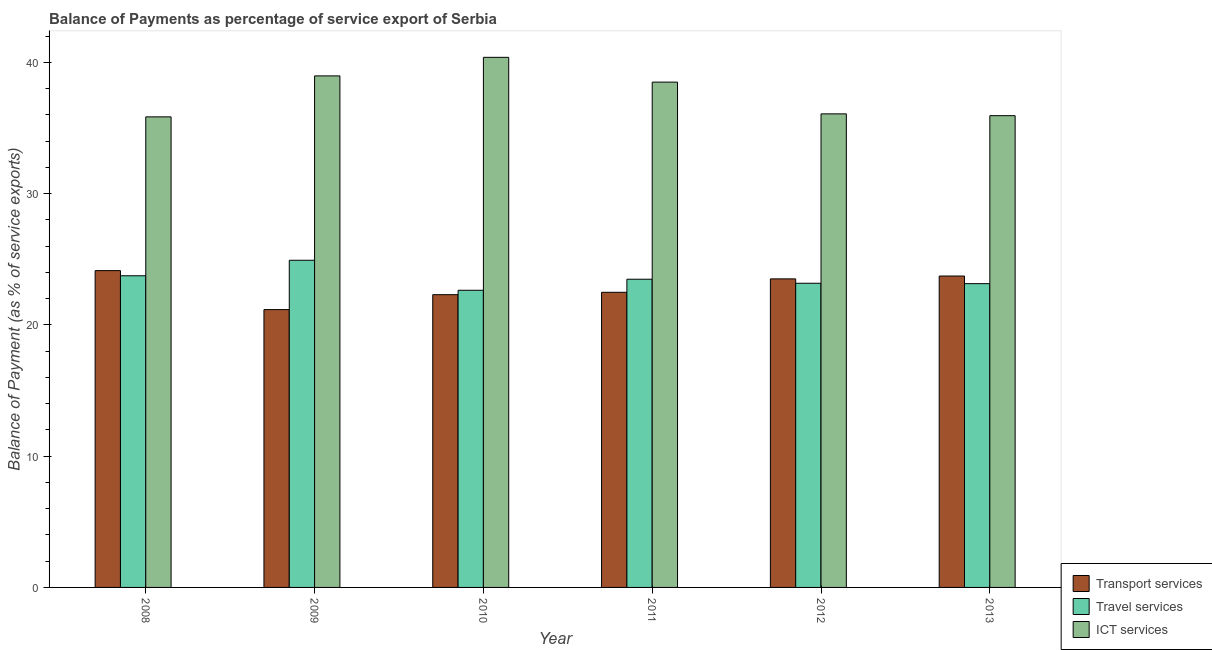How many groups of bars are there?
Give a very brief answer. 6. What is the label of the 3rd group of bars from the left?
Keep it short and to the point. 2010. What is the balance of payment of transport services in 2012?
Provide a succinct answer. 23.51. Across all years, what is the maximum balance of payment of travel services?
Ensure brevity in your answer.  24.93. Across all years, what is the minimum balance of payment of ict services?
Provide a short and direct response. 35.85. In which year was the balance of payment of travel services minimum?
Your answer should be compact. 2010. What is the total balance of payment of transport services in the graph?
Make the answer very short. 137.33. What is the difference between the balance of payment of ict services in 2009 and that in 2010?
Ensure brevity in your answer.  -1.41. What is the difference between the balance of payment of ict services in 2011 and the balance of payment of transport services in 2009?
Keep it short and to the point. -0.47. What is the average balance of payment of transport services per year?
Offer a very short reply. 22.89. In the year 2009, what is the difference between the balance of payment of travel services and balance of payment of ict services?
Make the answer very short. 0. In how many years, is the balance of payment of travel services greater than 4 %?
Provide a short and direct response. 6. What is the ratio of the balance of payment of transport services in 2009 to that in 2013?
Provide a succinct answer. 0.89. Is the difference between the balance of payment of travel services in 2010 and 2012 greater than the difference between the balance of payment of ict services in 2010 and 2012?
Keep it short and to the point. No. What is the difference between the highest and the second highest balance of payment of travel services?
Your answer should be very brief. 1.18. What is the difference between the highest and the lowest balance of payment of transport services?
Make the answer very short. 2.97. What does the 3rd bar from the left in 2013 represents?
Ensure brevity in your answer.  ICT services. What does the 3rd bar from the right in 2010 represents?
Provide a short and direct response. Transport services. How many years are there in the graph?
Ensure brevity in your answer.  6. Are the values on the major ticks of Y-axis written in scientific E-notation?
Your response must be concise. No. Where does the legend appear in the graph?
Ensure brevity in your answer.  Bottom right. How many legend labels are there?
Ensure brevity in your answer.  3. What is the title of the graph?
Provide a short and direct response. Balance of Payments as percentage of service export of Serbia. What is the label or title of the X-axis?
Keep it short and to the point. Year. What is the label or title of the Y-axis?
Your response must be concise. Balance of Payment (as % of service exports). What is the Balance of Payment (as % of service exports) in Transport services in 2008?
Make the answer very short. 24.14. What is the Balance of Payment (as % of service exports) of Travel services in 2008?
Give a very brief answer. 23.74. What is the Balance of Payment (as % of service exports) of ICT services in 2008?
Your response must be concise. 35.85. What is the Balance of Payment (as % of service exports) of Transport services in 2009?
Offer a terse response. 21.17. What is the Balance of Payment (as % of service exports) of Travel services in 2009?
Your response must be concise. 24.93. What is the Balance of Payment (as % of service exports) of ICT services in 2009?
Give a very brief answer. 38.97. What is the Balance of Payment (as % of service exports) in Transport services in 2010?
Keep it short and to the point. 22.3. What is the Balance of Payment (as % of service exports) of Travel services in 2010?
Ensure brevity in your answer.  22.64. What is the Balance of Payment (as % of service exports) of ICT services in 2010?
Provide a succinct answer. 40.39. What is the Balance of Payment (as % of service exports) in Transport services in 2011?
Give a very brief answer. 22.49. What is the Balance of Payment (as % of service exports) of Travel services in 2011?
Ensure brevity in your answer.  23.48. What is the Balance of Payment (as % of service exports) in ICT services in 2011?
Give a very brief answer. 38.5. What is the Balance of Payment (as % of service exports) in Transport services in 2012?
Keep it short and to the point. 23.51. What is the Balance of Payment (as % of service exports) of Travel services in 2012?
Offer a very short reply. 23.17. What is the Balance of Payment (as % of service exports) of ICT services in 2012?
Your answer should be very brief. 36.08. What is the Balance of Payment (as % of service exports) in Transport services in 2013?
Make the answer very short. 23.73. What is the Balance of Payment (as % of service exports) in Travel services in 2013?
Offer a very short reply. 23.15. What is the Balance of Payment (as % of service exports) in ICT services in 2013?
Offer a terse response. 35.94. Across all years, what is the maximum Balance of Payment (as % of service exports) in Transport services?
Offer a terse response. 24.14. Across all years, what is the maximum Balance of Payment (as % of service exports) in Travel services?
Make the answer very short. 24.93. Across all years, what is the maximum Balance of Payment (as % of service exports) of ICT services?
Provide a short and direct response. 40.39. Across all years, what is the minimum Balance of Payment (as % of service exports) of Transport services?
Give a very brief answer. 21.17. Across all years, what is the minimum Balance of Payment (as % of service exports) of Travel services?
Offer a very short reply. 22.64. Across all years, what is the minimum Balance of Payment (as % of service exports) of ICT services?
Your answer should be compact. 35.85. What is the total Balance of Payment (as % of service exports) in Transport services in the graph?
Keep it short and to the point. 137.33. What is the total Balance of Payment (as % of service exports) in Travel services in the graph?
Your answer should be very brief. 141.11. What is the total Balance of Payment (as % of service exports) in ICT services in the graph?
Your answer should be very brief. 225.73. What is the difference between the Balance of Payment (as % of service exports) of Transport services in 2008 and that in 2009?
Give a very brief answer. 2.97. What is the difference between the Balance of Payment (as % of service exports) in Travel services in 2008 and that in 2009?
Your answer should be very brief. -1.18. What is the difference between the Balance of Payment (as % of service exports) of ICT services in 2008 and that in 2009?
Keep it short and to the point. -3.12. What is the difference between the Balance of Payment (as % of service exports) of Transport services in 2008 and that in 2010?
Ensure brevity in your answer.  1.83. What is the difference between the Balance of Payment (as % of service exports) of Travel services in 2008 and that in 2010?
Your response must be concise. 1.1. What is the difference between the Balance of Payment (as % of service exports) in ICT services in 2008 and that in 2010?
Ensure brevity in your answer.  -4.54. What is the difference between the Balance of Payment (as % of service exports) of Transport services in 2008 and that in 2011?
Your answer should be very brief. 1.65. What is the difference between the Balance of Payment (as % of service exports) in Travel services in 2008 and that in 2011?
Your answer should be very brief. 0.26. What is the difference between the Balance of Payment (as % of service exports) in ICT services in 2008 and that in 2011?
Your response must be concise. -2.65. What is the difference between the Balance of Payment (as % of service exports) in Transport services in 2008 and that in 2012?
Offer a terse response. 0.63. What is the difference between the Balance of Payment (as % of service exports) of Travel services in 2008 and that in 2012?
Offer a very short reply. 0.57. What is the difference between the Balance of Payment (as % of service exports) in ICT services in 2008 and that in 2012?
Make the answer very short. -0.23. What is the difference between the Balance of Payment (as % of service exports) in Transport services in 2008 and that in 2013?
Offer a terse response. 0.41. What is the difference between the Balance of Payment (as % of service exports) in Travel services in 2008 and that in 2013?
Your answer should be compact. 0.6. What is the difference between the Balance of Payment (as % of service exports) in ICT services in 2008 and that in 2013?
Provide a short and direct response. -0.09. What is the difference between the Balance of Payment (as % of service exports) of Transport services in 2009 and that in 2010?
Your answer should be compact. -1.14. What is the difference between the Balance of Payment (as % of service exports) of Travel services in 2009 and that in 2010?
Ensure brevity in your answer.  2.29. What is the difference between the Balance of Payment (as % of service exports) of ICT services in 2009 and that in 2010?
Ensure brevity in your answer.  -1.41. What is the difference between the Balance of Payment (as % of service exports) of Transport services in 2009 and that in 2011?
Your answer should be compact. -1.32. What is the difference between the Balance of Payment (as % of service exports) in Travel services in 2009 and that in 2011?
Give a very brief answer. 1.45. What is the difference between the Balance of Payment (as % of service exports) of ICT services in 2009 and that in 2011?
Ensure brevity in your answer.  0.47. What is the difference between the Balance of Payment (as % of service exports) in Transport services in 2009 and that in 2012?
Provide a short and direct response. -2.34. What is the difference between the Balance of Payment (as % of service exports) in Travel services in 2009 and that in 2012?
Ensure brevity in your answer.  1.75. What is the difference between the Balance of Payment (as % of service exports) in ICT services in 2009 and that in 2012?
Your response must be concise. 2.89. What is the difference between the Balance of Payment (as % of service exports) in Transport services in 2009 and that in 2013?
Keep it short and to the point. -2.56. What is the difference between the Balance of Payment (as % of service exports) in Travel services in 2009 and that in 2013?
Provide a short and direct response. 1.78. What is the difference between the Balance of Payment (as % of service exports) in ICT services in 2009 and that in 2013?
Make the answer very short. 3.03. What is the difference between the Balance of Payment (as % of service exports) of Transport services in 2010 and that in 2011?
Offer a very short reply. -0.18. What is the difference between the Balance of Payment (as % of service exports) in Travel services in 2010 and that in 2011?
Your response must be concise. -0.84. What is the difference between the Balance of Payment (as % of service exports) in ICT services in 2010 and that in 2011?
Your answer should be very brief. 1.89. What is the difference between the Balance of Payment (as % of service exports) of Transport services in 2010 and that in 2012?
Keep it short and to the point. -1.2. What is the difference between the Balance of Payment (as % of service exports) of Travel services in 2010 and that in 2012?
Provide a succinct answer. -0.53. What is the difference between the Balance of Payment (as % of service exports) of ICT services in 2010 and that in 2012?
Your answer should be compact. 4.31. What is the difference between the Balance of Payment (as % of service exports) in Transport services in 2010 and that in 2013?
Your answer should be compact. -1.42. What is the difference between the Balance of Payment (as % of service exports) in Travel services in 2010 and that in 2013?
Provide a succinct answer. -0.51. What is the difference between the Balance of Payment (as % of service exports) of ICT services in 2010 and that in 2013?
Give a very brief answer. 4.45. What is the difference between the Balance of Payment (as % of service exports) of Transport services in 2011 and that in 2012?
Offer a terse response. -1.02. What is the difference between the Balance of Payment (as % of service exports) of Travel services in 2011 and that in 2012?
Provide a succinct answer. 0.31. What is the difference between the Balance of Payment (as % of service exports) of ICT services in 2011 and that in 2012?
Your answer should be compact. 2.42. What is the difference between the Balance of Payment (as % of service exports) of Transport services in 2011 and that in 2013?
Give a very brief answer. -1.24. What is the difference between the Balance of Payment (as % of service exports) of Travel services in 2011 and that in 2013?
Give a very brief answer. 0.34. What is the difference between the Balance of Payment (as % of service exports) in ICT services in 2011 and that in 2013?
Your answer should be very brief. 2.56. What is the difference between the Balance of Payment (as % of service exports) in Transport services in 2012 and that in 2013?
Your answer should be compact. -0.22. What is the difference between the Balance of Payment (as % of service exports) of Travel services in 2012 and that in 2013?
Give a very brief answer. 0.03. What is the difference between the Balance of Payment (as % of service exports) in ICT services in 2012 and that in 2013?
Provide a short and direct response. 0.14. What is the difference between the Balance of Payment (as % of service exports) of Transport services in 2008 and the Balance of Payment (as % of service exports) of Travel services in 2009?
Give a very brief answer. -0.79. What is the difference between the Balance of Payment (as % of service exports) of Transport services in 2008 and the Balance of Payment (as % of service exports) of ICT services in 2009?
Offer a terse response. -14.84. What is the difference between the Balance of Payment (as % of service exports) of Travel services in 2008 and the Balance of Payment (as % of service exports) of ICT services in 2009?
Offer a very short reply. -15.23. What is the difference between the Balance of Payment (as % of service exports) in Transport services in 2008 and the Balance of Payment (as % of service exports) in Travel services in 2010?
Provide a short and direct response. 1.5. What is the difference between the Balance of Payment (as % of service exports) of Transport services in 2008 and the Balance of Payment (as % of service exports) of ICT services in 2010?
Make the answer very short. -16.25. What is the difference between the Balance of Payment (as % of service exports) of Travel services in 2008 and the Balance of Payment (as % of service exports) of ICT services in 2010?
Your response must be concise. -16.64. What is the difference between the Balance of Payment (as % of service exports) of Transport services in 2008 and the Balance of Payment (as % of service exports) of Travel services in 2011?
Offer a very short reply. 0.66. What is the difference between the Balance of Payment (as % of service exports) of Transport services in 2008 and the Balance of Payment (as % of service exports) of ICT services in 2011?
Your answer should be compact. -14.36. What is the difference between the Balance of Payment (as % of service exports) in Travel services in 2008 and the Balance of Payment (as % of service exports) in ICT services in 2011?
Give a very brief answer. -14.75. What is the difference between the Balance of Payment (as % of service exports) in Transport services in 2008 and the Balance of Payment (as % of service exports) in ICT services in 2012?
Keep it short and to the point. -11.94. What is the difference between the Balance of Payment (as % of service exports) of Travel services in 2008 and the Balance of Payment (as % of service exports) of ICT services in 2012?
Provide a short and direct response. -12.34. What is the difference between the Balance of Payment (as % of service exports) in Transport services in 2008 and the Balance of Payment (as % of service exports) in ICT services in 2013?
Provide a succinct answer. -11.8. What is the difference between the Balance of Payment (as % of service exports) of Travel services in 2008 and the Balance of Payment (as % of service exports) of ICT services in 2013?
Offer a terse response. -12.2. What is the difference between the Balance of Payment (as % of service exports) in Transport services in 2009 and the Balance of Payment (as % of service exports) in Travel services in 2010?
Provide a succinct answer. -1.47. What is the difference between the Balance of Payment (as % of service exports) of Transport services in 2009 and the Balance of Payment (as % of service exports) of ICT services in 2010?
Your response must be concise. -19.22. What is the difference between the Balance of Payment (as % of service exports) of Travel services in 2009 and the Balance of Payment (as % of service exports) of ICT services in 2010?
Your response must be concise. -15.46. What is the difference between the Balance of Payment (as % of service exports) of Transport services in 2009 and the Balance of Payment (as % of service exports) of Travel services in 2011?
Provide a succinct answer. -2.31. What is the difference between the Balance of Payment (as % of service exports) in Transport services in 2009 and the Balance of Payment (as % of service exports) in ICT services in 2011?
Provide a succinct answer. -17.33. What is the difference between the Balance of Payment (as % of service exports) in Travel services in 2009 and the Balance of Payment (as % of service exports) in ICT services in 2011?
Give a very brief answer. -13.57. What is the difference between the Balance of Payment (as % of service exports) in Transport services in 2009 and the Balance of Payment (as % of service exports) in Travel services in 2012?
Keep it short and to the point. -2.01. What is the difference between the Balance of Payment (as % of service exports) in Transport services in 2009 and the Balance of Payment (as % of service exports) in ICT services in 2012?
Make the answer very short. -14.91. What is the difference between the Balance of Payment (as % of service exports) in Travel services in 2009 and the Balance of Payment (as % of service exports) in ICT services in 2012?
Your answer should be very brief. -11.15. What is the difference between the Balance of Payment (as % of service exports) of Transport services in 2009 and the Balance of Payment (as % of service exports) of Travel services in 2013?
Provide a short and direct response. -1.98. What is the difference between the Balance of Payment (as % of service exports) in Transport services in 2009 and the Balance of Payment (as % of service exports) in ICT services in 2013?
Give a very brief answer. -14.78. What is the difference between the Balance of Payment (as % of service exports) in Travel services in 2009 and the Balance of Payment (as % of service exports) in ICT services in 2013?
Your answer should be very brief. -11.01. What is the difference between the Balance of Payment (as % of service exports) in Transport services in 2010 and the Balance of Payment (as % of service exports) in Travel services in 2011?
Your response must be concise. -1.18. What is the difference between the Balance of Payment (as % of service exports) of Transport services in 2010 and the Balance of Payment (as % of service exports) of ICT services in 2011?
Your answer should be very brief. -16.2. What is the difference between the Balance of Payment (as % of service exports) in Travel services in 2010 and the Balance of Payment (as % of service exports) in ICT services in 2011?
Make the answer very short. -15.86. What is the difference between the Balance of Payment (as % of service exports) of Transport services in 2010 and the Balance of Payment (as % of service exports) of Travel services in 2012?
Your answer should be compact. -0.87. What is the difference between the Balance of Payment (as % of service exports) in Transport services in 2010 and the Balance of Payment (as % of service exports) in ICT services in 2012?
Your response must be concise. -13.78. What is the difference between the Balance of Payment (as % of service exports) of Travel services in 2010 and the Balance of Payment (as % of service exports) of ICT services in 2012?
Offer a very short reply. -13.44. What is the difference between the Balance of Payment (as % of service exports) of Transport services in 2010 and the Balance of Payment (as % of service exports) of Travel services in 2013?
Offer a terse response. -0.84. What is the difference between the Balance of Payment (as % of service exports) in Transport services in 2010 and the Balance of Payment (as % of service exports) in ICT services in 2013?
Offer a very short reply. -13.64. What is the difference between the Balance of Payment (as % of service exports) of Travel services in 2010 and the Balance of Payment (as % of service exports) of ICT services in 2013?
Provide a short and direct response. -13.3. What is the difference between the Balance of Payment (as % of service exports) in Transport services in 2011 and the Balance of Payment (as % of service exports) in Travel services in 2012?
Your response must be concise. -0.69. What is the difference between the Balance of Payment (as % of service exports) of Transport services in 2011 and the Balance of Payment (as % of service exports) of ICT services in 2012?
Ensure brevity in your answer.  -13.59. What is the difference between the Balance of Payment (as % of service exports) in Travel services in 2011 and the Balance of Payment (as % of service exports) in ICT services in 2012?
Make the answer very short. -12.6. What is the difference between the Balance of Payment (as % of service exports) in Transport services in 2011 and the Balance of Payment (as % of service exports) in Travel services in 2013?
Offer a very short reply. -0.66. What is the difference between the Balance of Payment (as % of service exports) of Transport services in 2011 and the Balance of Payment (as % of service exports) of ICT services in 2013?
Your answer should be very brief. -13.46. What is the difference between the Balance of Payment (as % of service exports) in Travel services in 2011 and the Balance of Payment (as % of service exports) in ICT services in 2013?
Your response must be concise. -12.46. What is the difference between the Balance of Payment (as % of service exports) in Transport services in 2012 and the Balance of Payment (as % of service exports) in Travel services in 2013?
Give a very brief answer. 0.36. What is the difference between the Balance of Payment (as % of service exports) in Transport services in 2012 and the Balance of Payment (as % of service exports) in ICT services in 2013?
Offer a very short reply. -12.44. What is the difference between the Balance of Payment (as % of service exports) of Travel services in 2012 and the Balance of Payment (as % of service exports) of ICT services in 2013?
Offer a very short reply. -12.77. What is the average Balance of Payment (as % of service exports) in Transport services per year?
Offer a very short reply. 22.89. What is the average Balance of Payment (as % of service exports) in Travel services per year?
Provide a succinct answer. 23.52. What is the average Balance of Payment (as % of service exports) in ICT services per year?
Provide a short and direct response. 37.62. In the year 2008, what is the difference between the Balance of Payment (as % of service exports) in Transport services and Balance of Payment (as % of service exports) in Travel services?
Provide a short and direct response. 0.39. In the year 2008, what is the difference between the Balance of Payment (as % of service exports) of Transport services and Balance of Payment (as % of service exports) of ICT services?
Give a very brief answer. -11.71. In the year 2008, what is the difference between the Balance of Payment (as % of service exports) in Travel services and Balance of Payment (as % of service exports) in ICT services?
Provide a short and direct response. -12.11. In the year 2009, what is the difference between the Balance of Payment (as % of service exports) in Transport services and Balance of Payment (as % of service exports) in Travel services?
Ensure brevity in your answer.  -3.76. In the year 2009, what is the difference between the Balance of Payment (as % of service exports) of Transport services and Balance of Payment (as % of service exports) of ICT services?
Your response must be concise. -17.81. In the year 2009, what is the difference between the Balance of Payment (as % of service exports) in Travel services and Balance of Payment (as % of service exports) in ICT services?
Your answer should be compact. -14.05. In the year 2010, what is the difference between the Balance of Payment (as % of service exports) of Transport services and Balance of Payment (as % of service exports) of Travel services?
Your answer should be compact. -0.34. In the year 2010, what is the difference between the Balance of Payment (as % of service exports) of Transport services and Balance of Payment (as % of service exports) of ICT services?
Keep it short and to the point. -18.08. In the year 2010, what is the difference between the Balance of Payment (as % of service exports) in Travel services and Balance of Payment (as % of service exports) in ICT services?
Make the answer very short. -17.75. In the year 2011, what is the difference between the Balance of Payment (as % of service exports) in Transport services and Balance of Payment (as % of service exports) in Travel services?
Provide a succinct answer. -0.99. In the year 2011, what is the difference between the Balance of Payment (as % of service exports) in Transport services and Balance of Payment (as % of service exports) in ICT services?
Give a very brief answer. -16.01. In the year 2011, what is the difference between the Balance of Payment (as % of service exports) of Travel services and Balance of Payment (as % of service exports) of ICT services?
Make the answer very short. -15.02. In the year 2012, what is the difference between the Balance of Payment (as % of service exports) in Transport services and Balance of Payment (as % of service exports) in Travel services?
Your response must be concise. 0.33. In the year 2012, what is the difference between the Balance of Payment (as % of service exports) of Transport services and Balance of Payment (as % of service exports) of ICT services?
Your response must be concise. -12.57. In the year 2012, what is the difference between the Balance of Payment (as % of service exports) of Travel services and Balance of Payment (as % of service exports) of ICT services?
Offer a terse response. -12.91. In the year 2013, what is the difference between the Balance of Payment (as % of service exports) in Transport services and Balance of Payment (as % of service exports) in Travel services?
Ensure brevity in your answer.  0.58. In the year 2013, what is the difference between the Balance of Payment (as % of service exports) in Transport services and Balance of Payment (as % of service exports) in ICT services?
Your response must be concise. -12.22. In the year 2013, what is the difference between the Balance of Payment (as % of service exports) of Travel services and Balance of Payment (as % of service exports) of ICT services?
Your response must be concise. -12.8. What is the ratio of the Balance of Payment (as % of service exports) of Transport services in 2008 to that in 2009?
Ensure brevity in your answer.  1.14. What is the ratio of the Balance of Payment (as % of service exports) of Travel services in 2008 to that in 2009?
Your response must be concise. 0.95. What is the ratio of the Balance of Payment (as % of service exports) of ICT services in 2008 to that in 2009?
Your response must be concise. 0.92. What is the ratio of the Balance of Payment (as % of service exports) of Transport services in 2008 to that in 2010?
Keep it short and to the point. 1.08. What is the ratio of the Balance of Payment (as % of service exports) in Travel services in 2008 to that in 2010?
Make the answer very short. 1.05. What is the ratio of the Balance of Payment (as % of service exports) of ICT services in 2008 to that in 2010?
Your response must be concise. 0.89. What is the ratio of the Balance of Payment (as % of service exports) in Transport services in 2008 to that in 2011?
Make the answer very short. 1.07. What is the ratio of the Balance of Payment (as % of service exports) in Travel services in 2008 to that in 2011?
Offer a very short reply. 1.01. What is the ratio of the Balance of Payment (as % of service exports) in ICT services in 2008 to that in 2011?
Ensure brevity in your answer.  0.93. What is the ratio of the Balance of Payment (as % of service exports) in Transport services in 2008 to that in 2012?
Ensure brevity in your answer.  1.03. What is the ratio of the Balance of Payment (as % of service exports) of Travel services in 2008 to that in 2012?
Give a very brief answer. 1.02. What is the ratio of the Balance of Payment (as % of service exports) in Transport services in 2008 to that in 2013?
Your answer should be very brief. 1.02. What is the ratio of the Balance of Payment (as % of service exports) in Travel services in 2008 to that in 2013?
Your answer should be very brief. 1.03. What is the ratio of the Balance of Payment (as % of service exports) of Transport services in 2009 to that in 2010?
Provide a short and direct response. 0.95. What is the ratio of the Balance of Payment (as % of service exports) of Travel services in 2009 to that in 2010?
Your answer should be very brief. 1.1. What is the ratio of the Balance of Payment (as % of service exports) in Transport services in 2009 to that in 2011?
Your response must be concise. 0.94. What is the ratio of the Balance of Payment (as % of service exports) in Travel services in 2009 to that in 2011?
Make the answer very short. 1.06. What is the ratio of the Balance of Payment (as % of service exports) in ICT services in 2009 to that in 2011?
Your response must be concise. 1.01. What is the ratio of the Balance of Payment (as % of service exports) of Transport services in 2009 to that in 2012?
Offer a very short reply. 0.9. What is the ratio of the Balance of Payment (as % of service exports) in Travel services in 2009 to that in 2012?
Offer a terse response. 1.08. What is the ratio of the Balance of Payment (as % of service exports) in ICT services in 2009 to that in 2012?
Keep it short and to the point. 1.08. What is the ratio of the Balance of Payment (as % of service exports) in Transport services in 2009 to that in 2013?
Provide a succinct answer. 0.89. What is the ratio of the Balance of Payment (as % of service exports) of Travel services in 2009 to that in 2013?
Your response must be concise. 1.08. What is the ratio of the Balance of Payment (as % of service exports) in ICT services in 2009 to that in 2013?
Give a very brief answer. 1.08. What is the ratio of the Balance of Payment (as % of service exports) of Travel services in 2010 to that in 2011?
Your answer should be compact. 0.96. What is the ratio of the Balance of Payment (as % of service exports) of ICT services in 2010 to that in 2011?
Ensure brevity in your answer.  1.05. What is the ratio of the Balance of Payment (as % of service exports) of Transport services in 2010 to that in 2012?
Give a very brief answer. 0.95. What is the ratio of the Balance of Payment (as % of service exports) of Travel services in 2010 to that in 2012?
Give a very brief answer. 0.98. What is the ratio of the Balance of Payment (as % of service exports) of ICT services in 2010 to that in 2012?
Provide a short and direct response. 1.12. What is the ratio of the Balance of Payment (as % of service exports) of Transport services in 2010 to that in 2013?
Offer a terse response. 0.94. What is the ratio of the Balance of Payment (as % of service exports) of Travel services in 2010 to that in 2013?
Ensure brevity in your answer.  0.98. What is the ratio of the Balance of Payment (as % of service exports) in ICT services in 2010 to that in 2013?
Your response must be concise. 1.12. What is the ratio of the Balance of Payment (as % of service exports) of Transport services in 2011 to that in 2012?
Offer a very short reply. 0.96. What is the ratio of the Balance of Payment (as % of service exports) in Travel services in 2011 to that in 2012?
Provide a succinct answer. 1.01. What is the ratio of the Balance of Payment (as % of service exports) in ICT services in 2011 to that in 2012?
Your answer should be compact. 1.07. What is the ratio of the Balance of Payment (as % of service exports) of Transport services in 2011 to that in 2013?
Your response must be concise. 0.95. What is the ratio of the Balance of Payment (as % of service exports) of Travel services in 2011 to that in 2013?
Your response must be concise. 1.01. What is the ratio of the Balance of Payment (as % of service exports) of ICT services in 2011 to that in 2013?
Offer a very short reply. 1.07. What is the ratio of the Balance of Payment (as % of service exports) of Transport services in 2012 to that in 2013?
Provide a short and direct response. 0.99. What is the difference between the highest and the second highest Balance of Payment (as % of service exports) in Transport services?
Your answer should be compact. 0.41. What is the difference between the highest and the second highest Balance of Payment (as % of service exports) in Travel services?
Offer a very short reply. 1.18. What is the difference between the highest and the second highest Balance of Payment (as % of service exports) in ICT services?
Ensure brevity in your answer.  1.41. What is the difference between the highest and the lowest Balance of Payment (as % of service exports) of Transport services?
Your answer should be very brief. 2.97. What is the difference between the highest and the lowest Balance of Payment (as % of service exports) in Travel services?
Give a very brief answer. 2.29. What is the difference between the highest and the lowest Balance of Payment (as % of service exports) in ICT services?
Your answer should be compact. 4.54. 